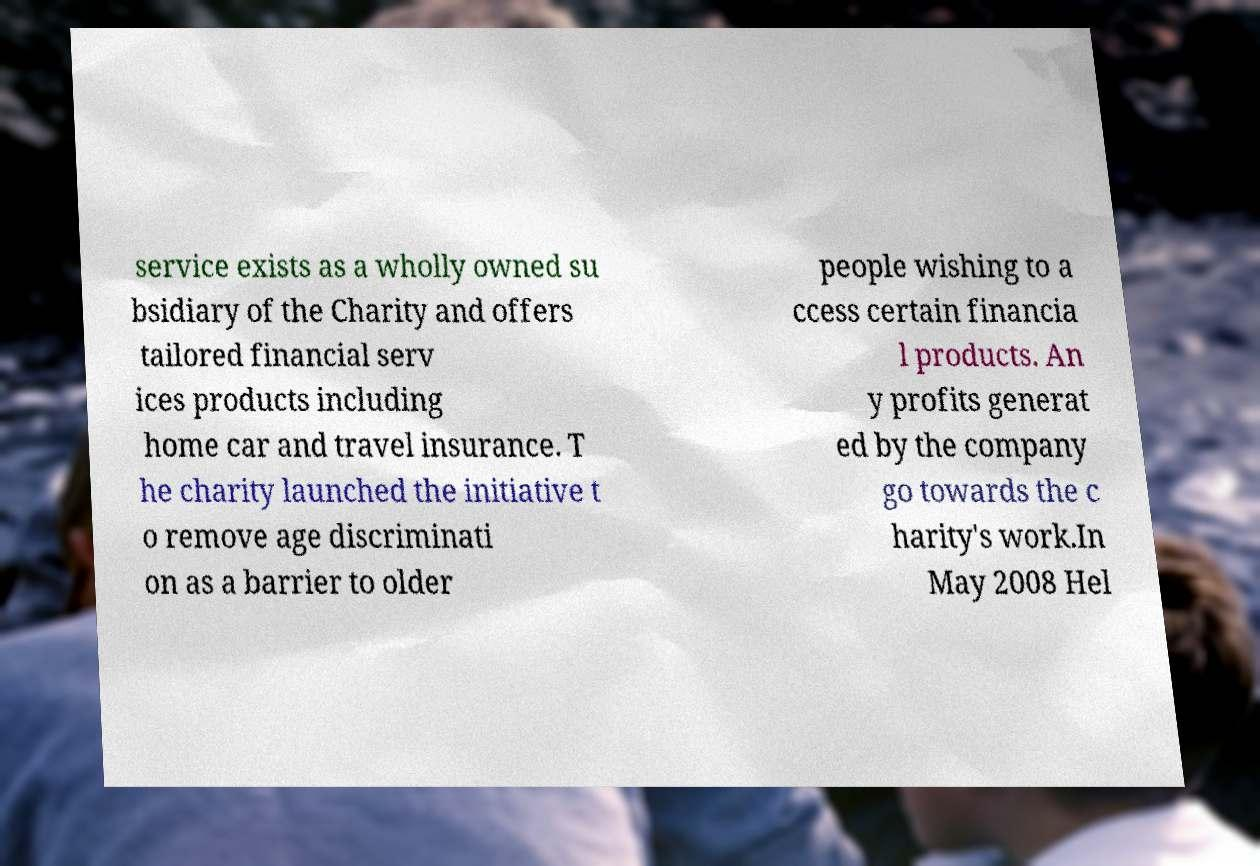For documentation purposes, I need the text within this image transcribed. Could you provide that? service exists as a wholly owned su bsidiary of the Charity and offers tailored financial serv ices products including home car and travel insurance. T he charity launched the initiative t o remove age discriminati on as a barrier to older people wishing to a ccess certain financia l products. An y profits generat ed by the company go towards the c harity's work.In May 2008 Hel 